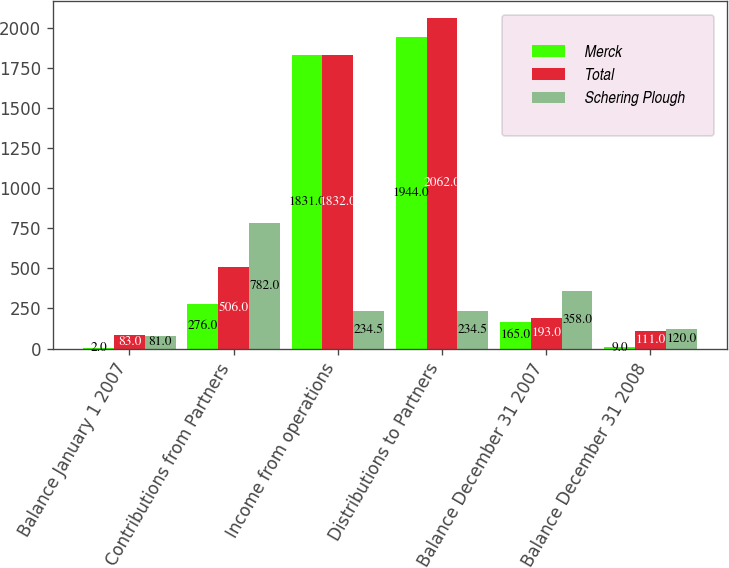Convert chart to OTSL. <chart><loc_0><loc_0><loc_500><loc_500><stacked_bar_chart><ecel><fcel>Balance January 1 2007<fcel>Contributions from Partners<fcel>Income from operations<fcel>Distributions to Partners<fcel>Balance December 31 2007<fcel>Balance December 31 2008<nl><fcel>Merck<fcel>2<fcel>276<fcel>1831<fcel>1944<fcel>165<fcel>9<nl><fcel>Total<fcel>83<fcel>506<fcel>1832<fcel>2062<fcel>193<fcel>111<nl><fcel>Schering Plough<fcel>81<fcel>782<fcel>234.5<fcel>234.5<fcel>358<fcel>120<nl></chart> 